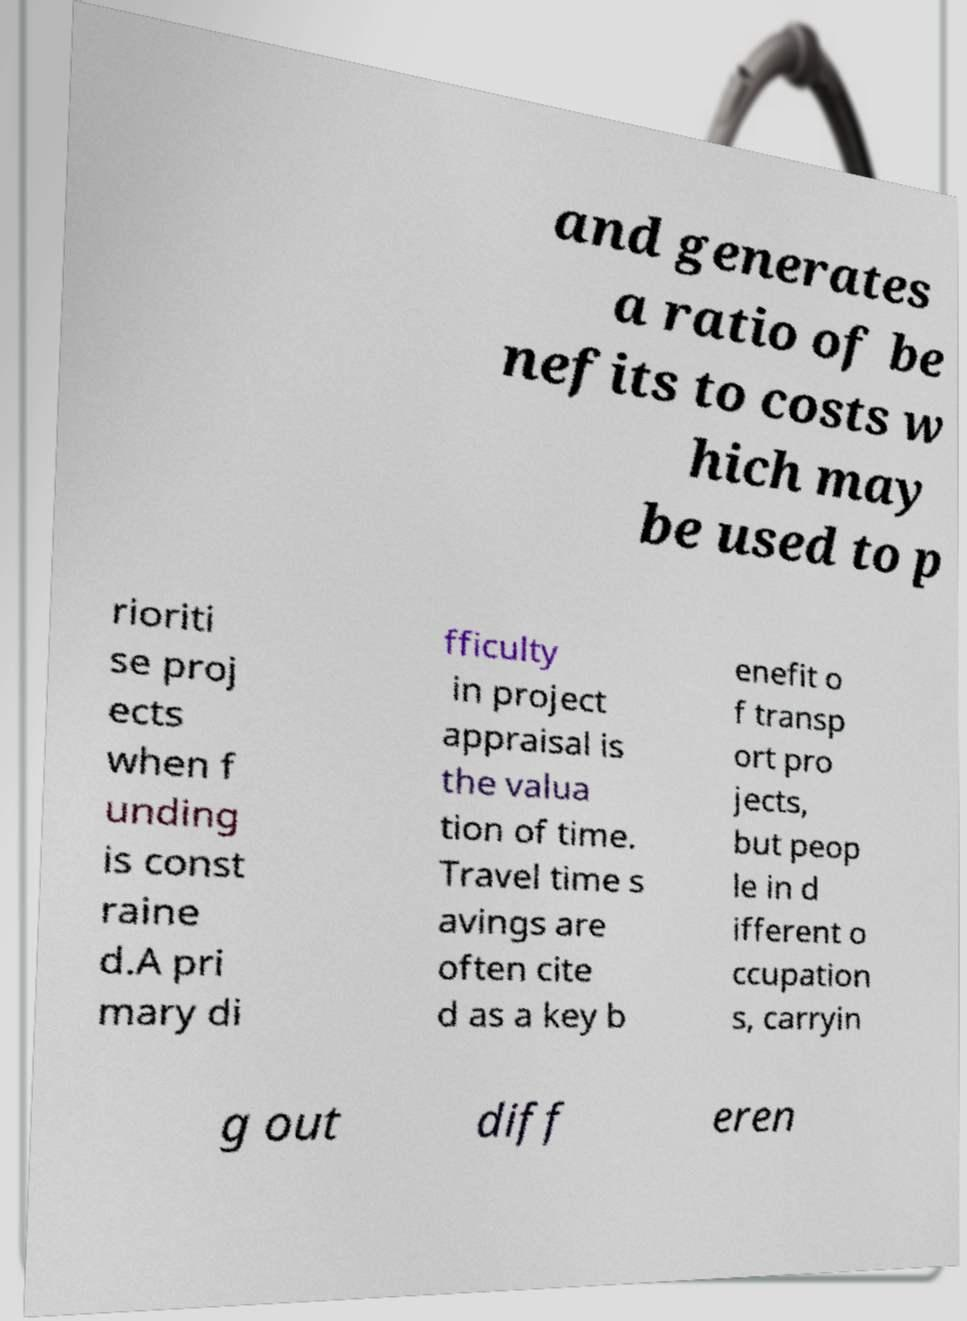Could you assist in decoding the text presented in this image and type it out clearly? and generates a ratio of be nefits to costs w hich may be used to p rioriti se proj ects when f unding is const raine d.A pri mary di fficulty in project appraisal is the valua tion of time. Travel time s avings are often cite d as a key b enefit o f transp ort pro jects, but peop le in d ifferent o ccupation s, carryin g out diff eren 